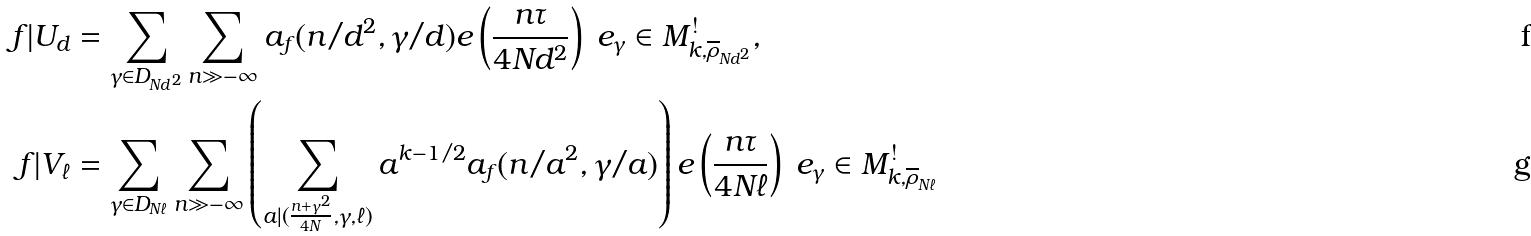Convert formula to latex. <formula><loc_0><loc_0><loc_500><loc_500>f | U _ { d } & = \sum _ { \gamma \in D _ { N d ^ { 2 } } } \sum _ { n \gg - \infty } a _ { f } ( n / d ^ { 2 } , \gamma / d ) e \left ( \frac { n \tau } { 4 N d ^ { 2 } } \right ) \ e _ { \gamma } \in M _ { k , \overline { \rho } _ { N d ^ { 2 } } } ^ { ! } , \\ f | V _ { \ell } & = \sum _ { \gamma \in D _ { N \ell } } \sum _ { n \gg - \infty } \left ( \sum _ { a | ( \frac { n + \gamma ^ { 2 } } { 4 N } , \gamma , \ell ) } a ^ { k - 1 / 2 } a _ { f } ( n / a ^ { 2 } , \gamma / a ) \right ) e \left ( \frac { n \tau } { 4 N \ell } \right ) \ e _ { \gamma } \in M _ { k , \overline { \rho } _ { N \ell } } ^ { ! }</formula> 